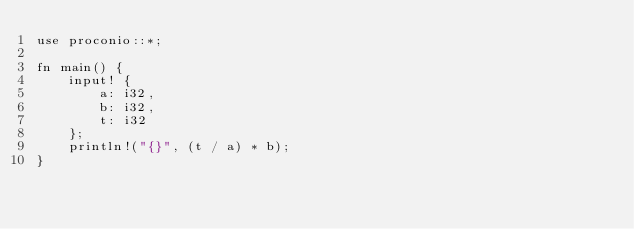<code> <loc_0><loc_0><loc_500><loc_500><_Rust_>use proconio::*;

fn main() {
    input! {
        a: i32,
        b: i32,
        t: i32
    };
    println!("{}", (t / a) * b);
}
</code> 